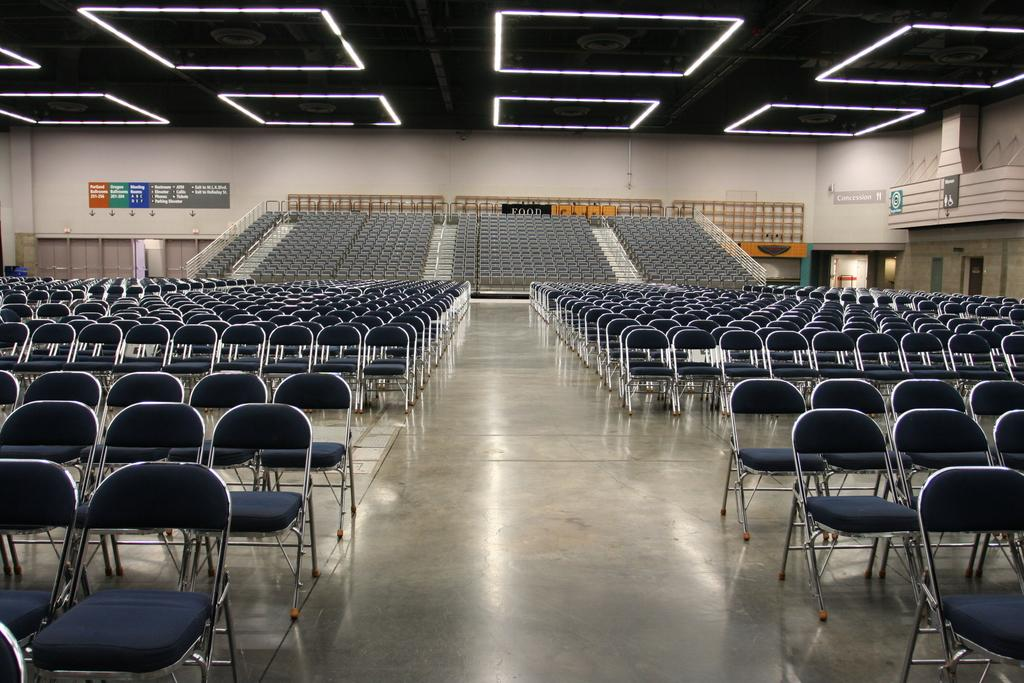What objects are present in the image that are not occupied? There are empty chairs in the image. What can be seen on the boards in the background of the image? There are boards with text in the background of the image. What type of structure is visible in the background of the image? There is a wall in the background of the image. What type of cart is being used by the minister in the image? There is no cart or minister present in the image. 